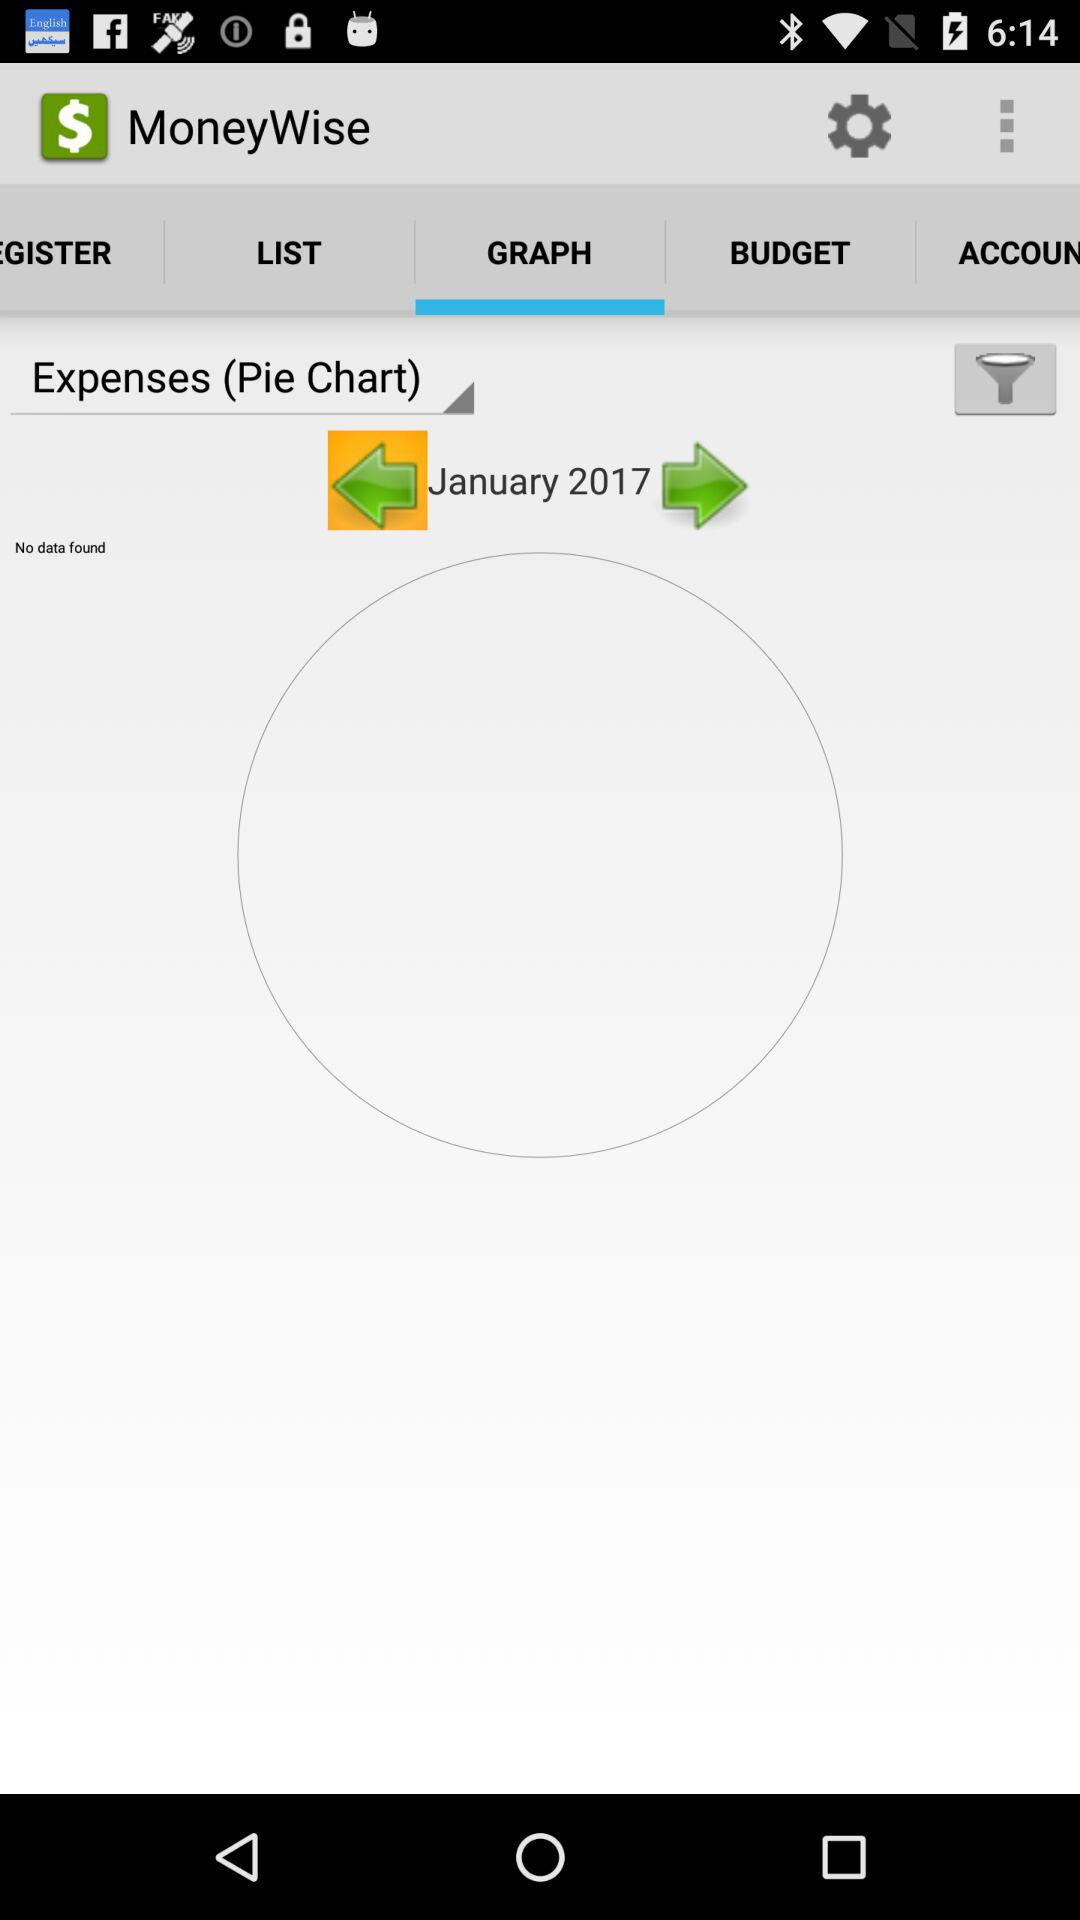Which tab is selected? The selected tab is Graph. 